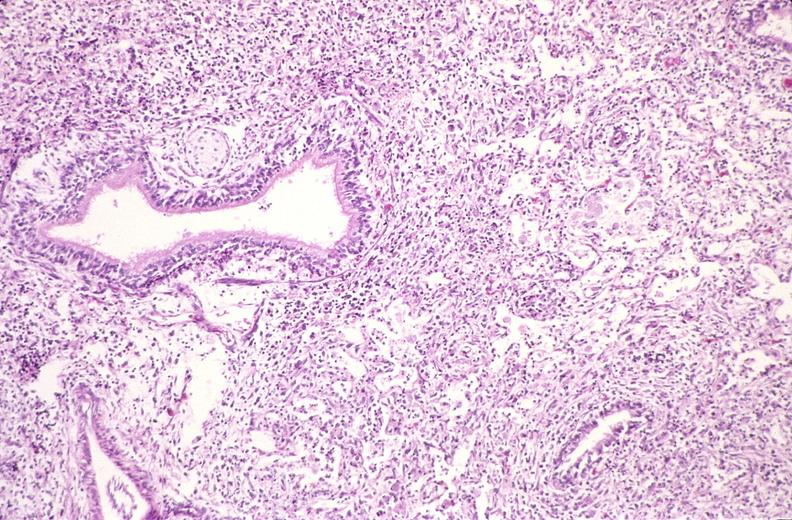where is this?
Answer the question using a single word or phrase. Lung 